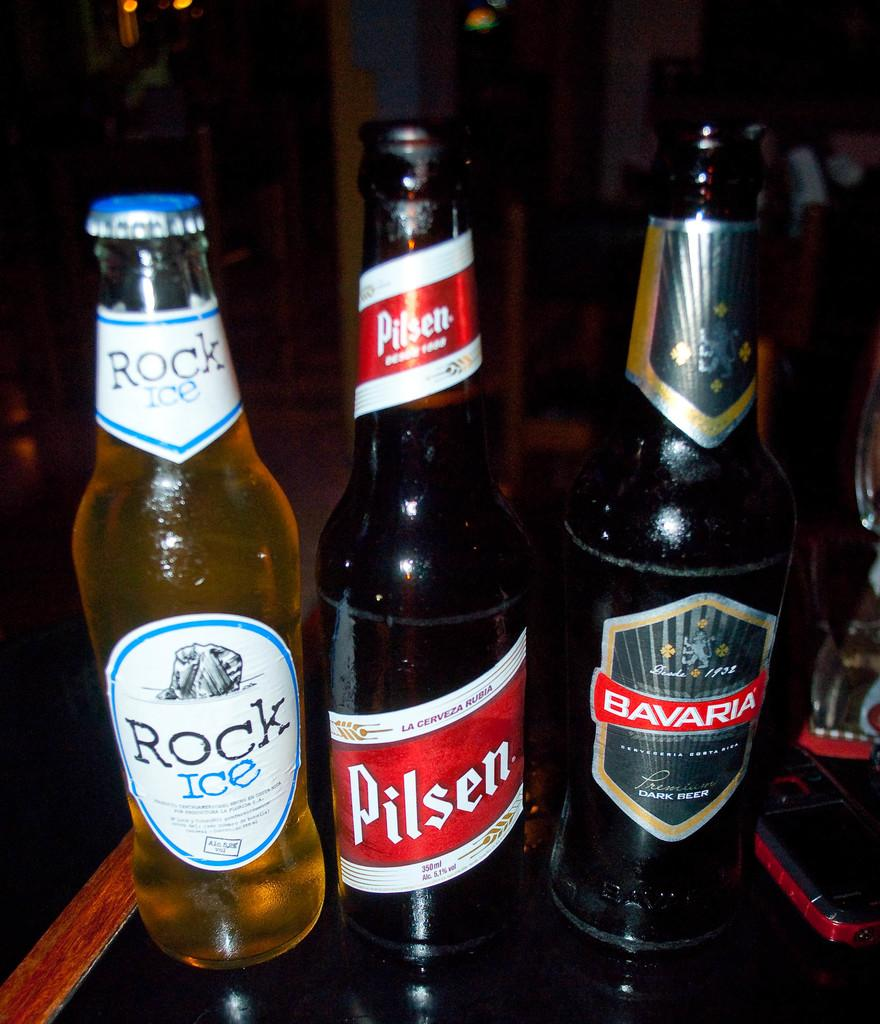Provide a one-sentence caption for the provided image. A bottle of Rock Ice, Pilsen, and Bavaria are lined up next to each other. 